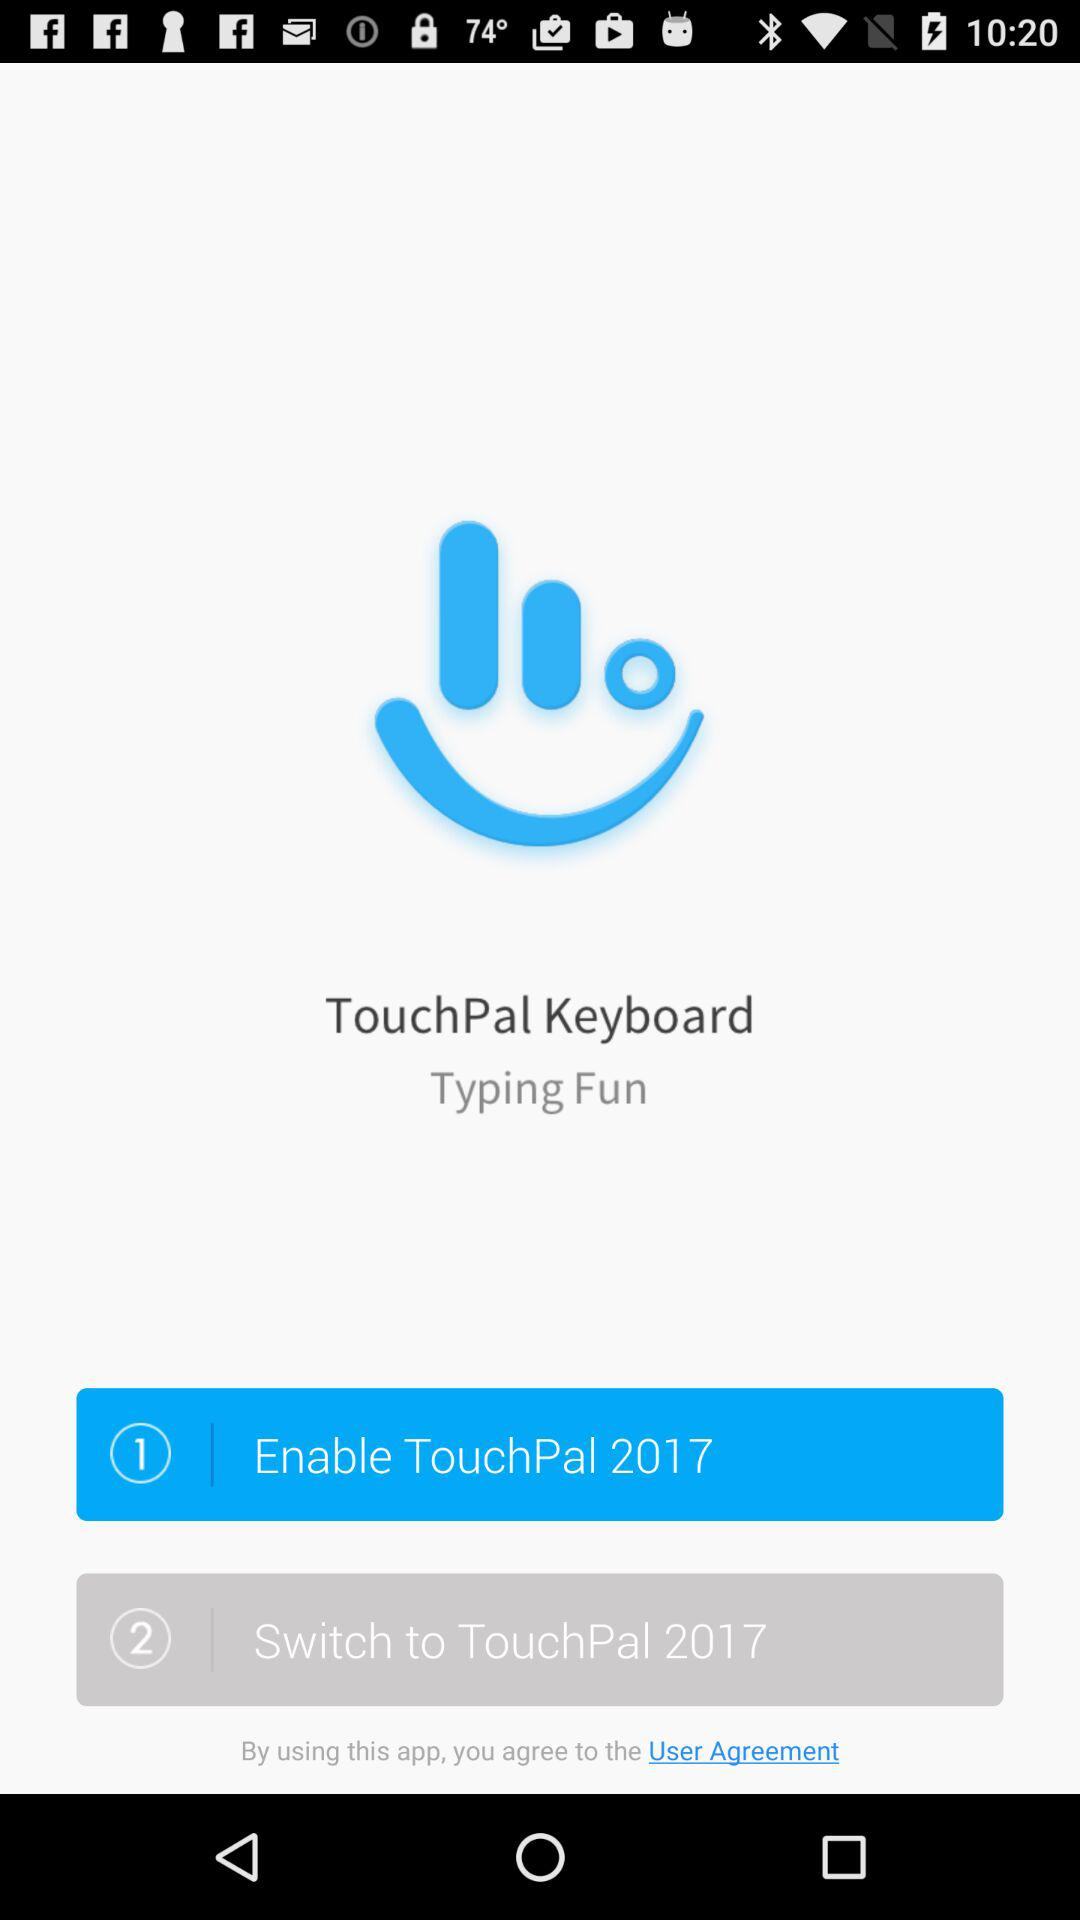What is the application name? The application name is "TouchPal". 